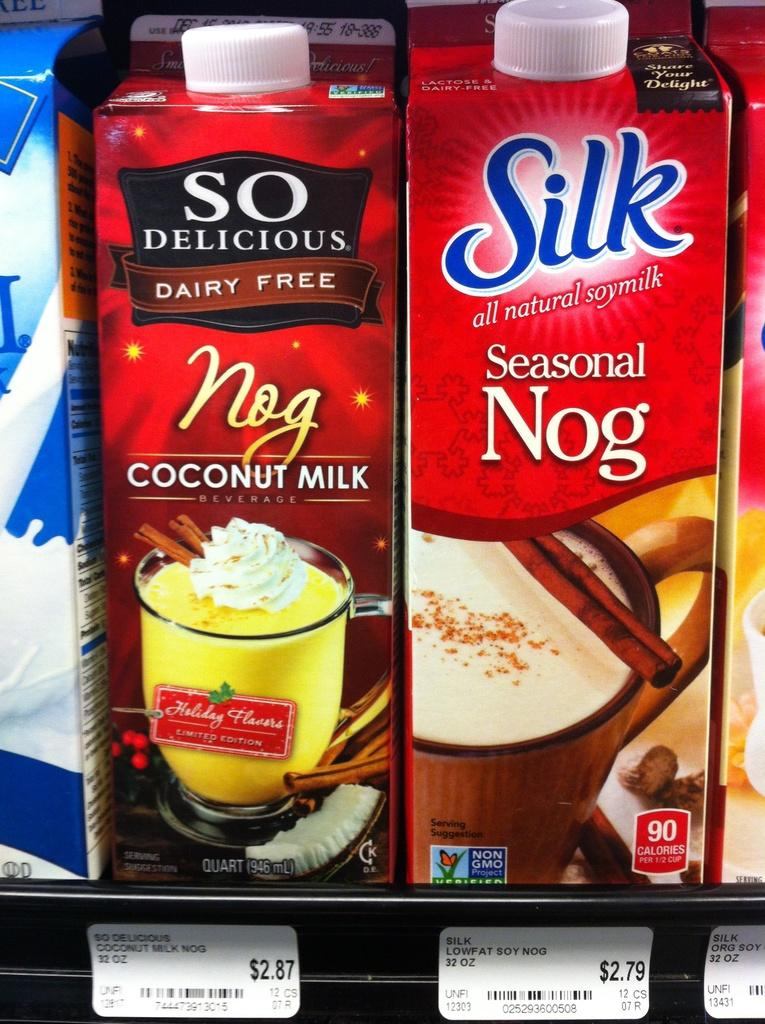What type of packaging is visible in the image? There are tetra packs in the image. What can be found on the tetra packs? The tetra packs have text and images on them. How are the tetra packs arranged in the image? The tetra packs are on racks. What else can be found in the image besides the tetra packs? There are cards with text in the image. Can you see any gloves being used to handle the tetra packs in the image? There are no gloves visible in the image; the tetra packs are on racks. How many ducks are swimming in the tetra packs in the image? There are no ducks present in the image; it features tetra packs on racks and cards with text. 